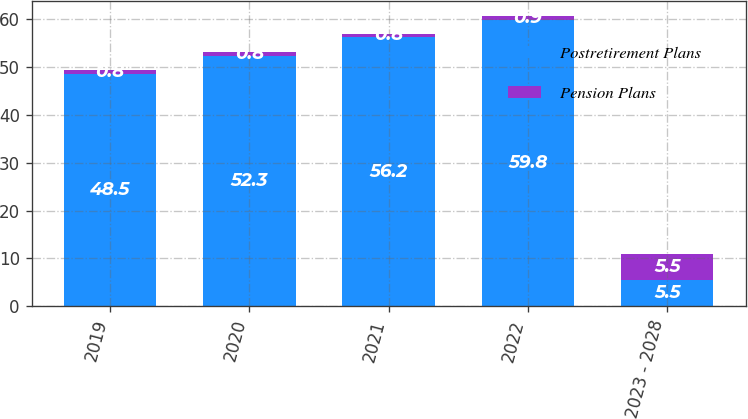Convert chart. <chart><loc_0><loc_0><loc_500><loc_500><stacked_bar_chart><ecel><fcel>2019<fcel>2020<fcel>2021<fcel>2022<fcel>2023 - 2028<nl><fcel>Postretirement Plans<fcel>48.5<fcel>52.3<fcel>56.2<fcel>59.8<fcel>5.5<nl><fcel>Pension Plans<fcel>0.8<fcel>0.8<fcel>0.8<fcel>0.9<fcel>5.5<nl></chart> 